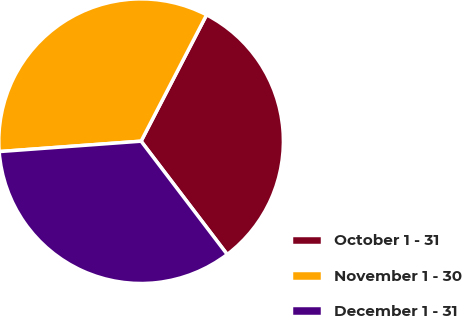<chart> <loc_0><loc_0><loc_500><loc_500><pie_chart><fcel>October 1 - 31<fcel>November 1 - 30<fcel>December 1 - 31<nl><fcel>32.04%<fcel>33.77%<fcel>34.18%<nl></chart> 